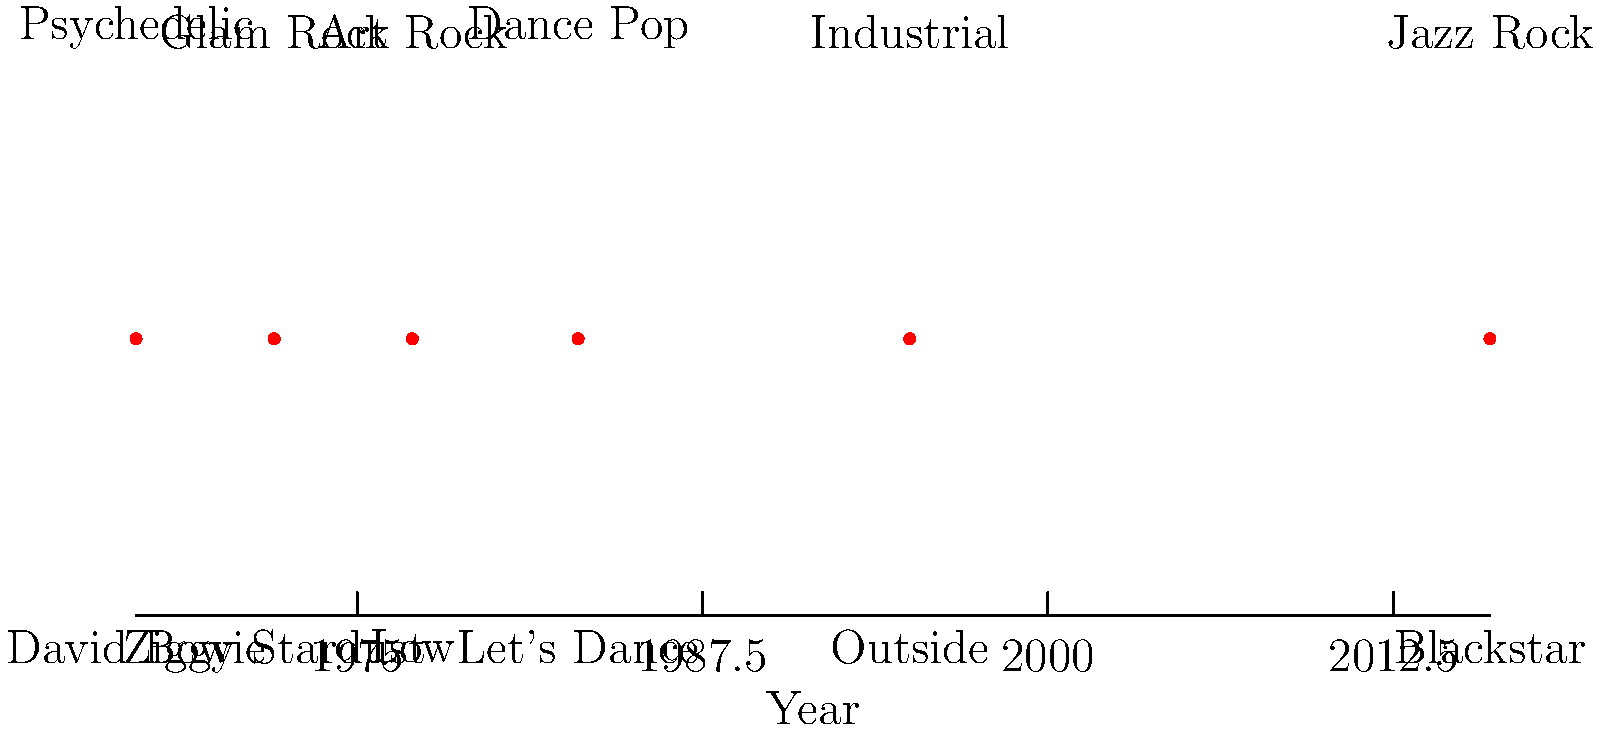Analyze the timeline of David Bowie's musical evolution. Which album marked his transition into the Dance Pop era, and in what year was it released? To answer this question, we need to follow these steps:

1. Examine the timeline carefully, looking at both the album names and the musical styles associated with each point.

2. Identify the point on the timeline where "Dance Pop" is mentioned as the musical style.

3. Once we locate "Dance Pop," we need to look at the album name directly below it.

4. The album associated with the "Dance Pop" style is "Let's Dance."

5. To determine the year, we need to look at the x-axis value corresponding to this point.

6. The year associated with "Let's Dance" and "Dance Pop" is 1983.

Therefore, the album that marked David Bowie's transition into the Dance Pop era was "Let's Dance," released in 1983.
Answer: Let's Dance, 1983 